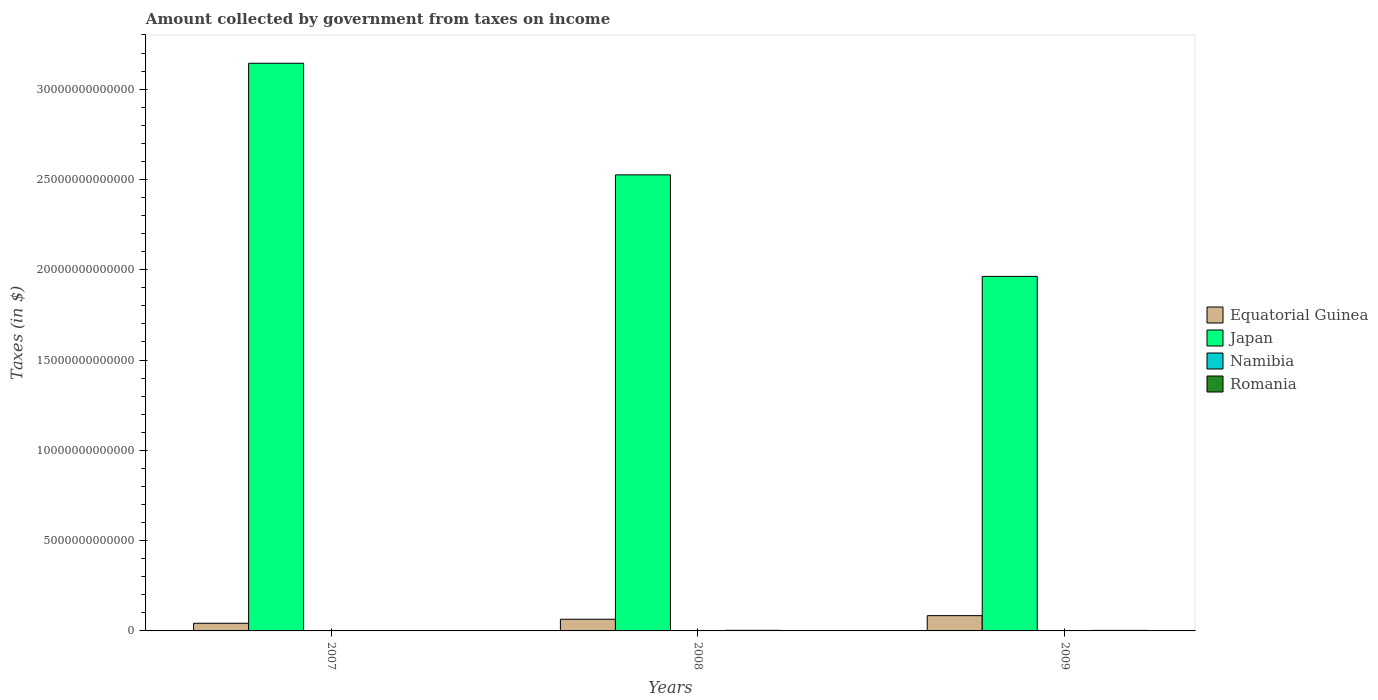How many bars are there on the 3rd tick from the right?
Offer a terse response. 4. What is the label of the 3rd group of bars from the left?
Ensure brevity in your answer.  2009. What is the amount collected by government from taxes on income in Romania in 2007?
Make the answer very short. 1.50e+1. Across all years, what is the maximum amount collected by government from taxes on income in Namibia?
Your response must be concise. 8.14e+09. Across all years, what is the minimum amount collected by government from taxes on income in Equatorial Guinea?
Offer a terse response. 4.24e+11. In which year was the amount collected by government from taxes on income in Japan maximum?
Ensure brevity in your answer.  2007. What is the total amount collected by government from taxes on income in Equatorial Guinea in the graph?
Offer a very short reply. 1.92e+12. What is the difference between the amount collected by government from taxes on income in Romania in 2008 and that in 2009?
Provide a short and direct response. 3.39e+09. What is the difference between the amount collected by government from taxes on income in Equatorial Guinea in 2007 and the amount collected by government from taxes on income in Namibia in 2009?
Your answer should be very brief. 4.16e+11. What is the average amount collected by government from taxes on income in Romania per year?
Offer a very short reply. 2.65e+1. In the year 2008, what is the difference between the amount collected by government from taxes on income in Namibia and amount collected by government from taxes on income in Equatorial Guinea?
Keep it short and to the point. -6.39e+11. In how many years, is the amount collected by government from taxes on income in Namibia greater than 23000000000000 $?
Offer a very short reply. 0. What is the ratio of the amount collected by government from taxes on income in Japan in 2007 to that in 2009?
Your answer should be very brief. 1.6. Is the amount collected by government from taxes on income in Romania in 2007 less than that in 2009?
Provide a short and direct response. Yes. Is the difference between the amount collected by government from taxes on income in Namibia in 2007 and 2008 greater than the difference between the amount collected by government from taxes on income in Equatorial Guinea in 2007 and 2008?
Make the answer very short. Yes. What is the difference between the highest and the second highest amount collected by government from taxes on income in Namibia?
Make the answer very short. 6.70e+07. What is the difference between the highest and the lowest amount collected by government from taxes on income in Japan?
Provide a succinct answer. 1.18e+13. In how many years, is the amount collected by government from taxes on income in Equatorial Guinea greater than the average amount collected by government from taxes on income in Equatorial Guinea taken over all years?
Keep it short and to the point. 2. Is it the case that in every year, the sum of the amount collected by government from taxes on income in Equatorial Guinea and amount collected by government from taxes on income in Japan is greater than the sum of amount collected by government from taxes on income in Namibia and amount collected by government from taxes on income in Romania?
Your response must be concise. Yes. What does the 1st bar from the left in 2009 represents?
Make the answer very short. Equatorial Guinea. What does the 2nd bar from the right in 2007 represents?
Offer a very short reply. Namibia. Is it the case that in every year, the sum of the amount collected by government from taxes on income in Equatorial Guinea and amount collected by government from taxes on income in Romania is greater than the amount collected by government from taxes on income in Namibia?
Your answer should be compact. Yes. Are all the bars in the graph horizontal?
Offer a very short reply. No. What is the difference between two consecutive major ticks on the Y-axis?
Ensure brevity in your answer.  5.00e+12. Does the graph contain any zero values?
Make the answer very short. No. Where does the legend appear in the graph?
Your response must be concise. Center right. What is the title of the graph?
Keep it short and to the point. Amount collected by government from taxes on income. What is the label or title of the Y-axis?
Keep it short and to the point. Taxes (in $). What is the Taxes (in $) of Equatorial Guinea in 2007?
Provide a short and direct response. 4.24e+11. What is the Taxes (in $) in Japan in 2007?
Your answer should be compact. 3.14e+13. What is the Taxes (in $) in Namibia in 2007?
Keep it short and to the point. 5.20e+09. What is the Taxes (in $) of Romania in 2007?
Provide a succinct answer. 1.50e+1. What is the Taxes (in $) in Equatorial Guinea in 2008?
Your response must be concise. 6.47e+11. What is the Taxes (in $) in Japan in 2008?
Offer a terse response. 2.53e+13. What is the Taxes (in $) of Namibia in 2008?
Your response must be concise. 8.07e+09. What is the Taxes (in $) of Romania in 2008?
Provide a short and direct response. 3.40e+1. What is the Taxes (in $) in Equatorial Guinea in 2009?
Give a very brief answer. 8.46e+11. What is the Taxes (in $) in Japan in 2009?
Provide a succinct answer. 1.96e+13. What is the Taxes (in $) in Namibia in 2009?
Your answer should be very brief. 8.14e+09. What is the Taxes (in $) in Romania in 2009?
Provide a short and direct response. 3.06e+1. Across all years, what is the maximum Taxes (in $) of Equatorial Guinea?
Your response must be concise. 8.46e+11. Across all years, what is the maximum Taxes (in $) in Japan?
Provide a succinct answer. 3.14e+13. Across all years, what is the maximum Taxes (in $) in Namibia?
Offer a very short reply. 8.14e+09. Across all years, what is the maximum Taxes (in $) in Romania?
Provide a short and direct response. 3.40e+1. Across all years, what is the minimum Taxes (in $) in Equatorial Guinea?
Make the answer very short. 4.24e+11. Across all years, what is the minimum Taxes (in $) in Japan?
Give a very brief answer. 1.96e+13. Across all years, what is the minimum Taxes (in $) of Namibia?
Offer a very short reply. 5.20e+09. Across all years, what is the minimum Taxes (in $) of Romania?
Ensure brevity in your answer.  1.50e+1. What is the total Taxes (in $) of Equatorial Guinea in the graph?
Your answer should be very brief. 1.92e+12. What is the total Taxes (in $) of Japan in the graph?
Provide a succinct answer. 7.63e+13. What is the total Taxes (in $) in Namibia in the graph?
Offer a terse response. 2.14e+1. What is the total Taxes (in $) in Romania in the graph?
Make the answer very short. 7.96e+1. What is the difference between the Taxes (in $) in Equatorial Guinea in 2007 and that in 2008?
Provide a short and direct response. -2.23e+11. What is the difference between the Taxes (in $) of Japan in 2007 and that in 2008?
Keep it short and to the point. 6.18e+12. What is the difference between the Taxes (in $) of Namibia in 2007 and that in 2008?
Ensure brevity in your answer.  -2.87e+09. What is the difference between the Taxes (in $) of Romania in 2007 and that in 2008?
Ensure brevity in your answer.  -1.90e+1. What is the difference between the Taxes (in $) of Equatorial Guinea in 2007 and that in 2009?
Make the answer very short. -4.22e+11. What is the difference between the Taxes (in $) in Japan in 2007 and that in 2009?
Provide a short and direct response. 1.18e+13. What is the difference between the Taxes (in $) in Namibia in 2007 and that in 2009?
Offer a terse response. -2.94e+09. What is the difference between the Taxes (in $) of Romania in 2007 and that in 2009?
Keep it short and to the point. -1.56e+1. What is the difference between the Taxes (in $) in Equatorial Guinea in 2008 and that in 2009?
Provide a short and direct response. -1.99e+11. What is the difference between the Taxes (in $) in Japan in 2008 and that in 2009?
Offer a terse response. 5.62e+12. What is the difference between the Taxes (in $) in Namibia in 2008 and that in 2009?
Your answer should be very brief. -6.70e+07. What is the difference between the Taxes (in $) of Romania in 2008 and that in 2009?
Make the answer very short. 3.39e+09. What is the difference between the Taxes (in $) in Equatorial Guinea in 2007 and the Taxes (in $) in Japan in 2008?
Keep it short and to the point. -2.48e+13. What is the difference between the Taxes (in $) of Equatorial Guinea in 2007 and the Taxes (in $) of Namibia in 2008?
Keep it short and to the point. 4.16e+11. What is the difference between the Taxes (in $) of Equatorial Guinea in 2007 and the Taxes (in $) of Romania in 2008?
Your response must be concise. 3.90e+11. What is the difference between the Taxes (in $) of Japan in 2007 and the Taxes (in $) of Namibia in 2008?
Provide a succinct answer. 3.14e+13. What is the difference between the Taxes (in $) in Japan in 2007 and the Taxes (in $) in Romania in 2008?
Offer a very short reply. 3.14e+13. What is the difference between the Taxes (in $) of Namibia in 2007 and the Taxes (in $) of Romania in 2008?
Offer a very short reply. -2.88e+1. What is the difference between the Taxes (in $) of Equatorial Guinea in 2007 and the Taxes (in $) of Japan in 2009?
Keep it short and to the point. -1.92e+13. What is the difference between the Taxes (in $) in Equatorial Guinea in 2007 and the Taxes (in $) in Namibia in 2009?
Ensure brevity in your answer.  4.16e+11. What is the difference between the Taxes (in $) in Equatorial Guinea in 2007 and the Taxes (in $) in Romania in 2009?
Make the answer very short. 3.93e+11. What is the difference between the Taxes (in $) of Japan in 2007 and the Taxes (in $) of Namibia in 2009?
Ensure brevity in your answer.  3.14e+13. What is the difference between the Taxes (in $) of Japan in 2007 and the Taxes (in $) of Romania in 2009?
Offer a very short reply. 3.14e+13. What is the difference between the Taxes (in $) of Namibia in 2007 and the Taxes (in $) of Romania in 2009?
Ensure brevity in your answer.  -2.54e+1. What is the difference between the Taxes (in $) in Equatorial Guinea in 2008 and the Taxes (in $) in Japan in 2009?
Ensure brevity in your answer.  -1.90e+13. What is the difference between the Taxes (in $) of Equatorial Guinea in 2008 and the Taxes (in $) of Namibia in 2009?
Offer a very short reply. 6.39e+11. What is the difference between the Taxes (in $) in Equatorial Guinea in 2008 and the Taxes (in $) in Romania in 2009?
Keep it short and to the point. 6.16e+11. What is the difference between the Taxes (in $) of Japan in 2008 and the Taxes (in $) of Namibia in 2009?
Ensure brevity in your answer.  2.52e+13. What is the difference between the Taxes (in $) in Japan in 2008 and the Taxes (in $) in Romania in 2009?
Your answer should be very brief. 2.52e+13. What is the difference between the Taxes (in $) in Namibia in 2008 and the Taxes (in $) in Romania in 2009?
Your response must be concise. -2.25e+1. What is the average Taxes (in $) in Equatorial Guinea per year?
Provide a short and direct response. 6.39e+11. What is the average Taxes (in $) in Japan per year?
Your answer should be very brief. 2.54e+13. What is the average Taxes (in $) of Namibia per year?
Offer a very short reply. 7.14e+09. What is the average Taxes (in $) in Romania per year?
Your response must be concise. 2.65e+1. In the year 2007, what is the difference between the Taxes (in $) of Equatorial Guinea and Taxes (in $) of Japan?
Your answer should be compact. -3.10e+13. In the year 2007, what is the difference between the Taxes (in $) of Equatorial Guinea and Taxes (in $) of Namibia?
Offer a very short reply. 4.19e+11. In the year 2007, what is the difference between the Taxes (in $) of Equatorial Guinea and Taxes (in $) of Romania?
Make the answer very short. 4.09e+11. In the year 2007, what is the difference between the Taxes (in $) in Japan and Taxes (in $) in Namibia?
Give a very brief answer. 3.14e+13. In the year 2007, what is the difference between the Taxes (in $) of Japan and Taxes (in $) of Romania?
Offer a very short reply. 3.14e+13. In the year 2007, what is the difference between the Taxes (in $) in Namibia and Taxes (in $) in Romania?
Your response must be concise. -9.82e+09. In the year 2008, what is the difference between the Taxes (in $) in Equatorial Guinea and Taxes (in $) in Japan?
Provide a succinct answer. -2.46e+13. In the year 2008, what is the difference between the Taxes (in $) of Equatorial Guinea and Taxes (in $) of Namibia?
Give a very brief answer. 6.39e+11. In the year 2008, what is the difference between the Taxes (in $) in Equatorial Guinea and Taxes (in $) in Romania?
Your response must be concise. 6.13e+11. In the year 2008, what is the difference between the Taxes (in $) of Japan and Taxes (in $) of Namibia?
Keep it short and to the point. 2.52e+13. In the year 2008, what is the difference between the Taxes (in $) of Japan and Taxes (in $) of Romania?
Give a very brief answer. 2.52e+13. In the year 2008, what is the difference between the Taxes (in $) of Namibia and Taxes (in $) of Romania?
Offer a very short reply. -2.59e+1. In the year 2009, what is the difference between the Taxes (in $) in Equatorial Guinea and Taxes (in $) in Japan?
Offer a terse response. -1.88e+13. In the year 2009, what is the difference between the Taxes (in $) of Equatorial Guinea and Taxes (in $) of Namibia?
Your answer should be very brief. 8.38e+11. In the year 2009, what is the difference between the Taxes (in $) of Equatorial Guinea and Taxes (in $) of Romania?
Provide a succinct answer. 8.16e+11. In the year 2009, what is the difference between the Taxes (in $) in Japan and Taxes (in $) in Namibia?
Provide a short and direct response. 1.96e+13. In the year 2009, what is the difference between the Taxes (in $) of Japan and Taxes (in $) of Romania?
Give a very brief answer. 1.96e+13. In the year 2009, what is the difference between the Taxes (in $) in Namibia and Taxes (in $) in Romania?
Ensure brevity in your answer.  -2.25e+1. What is the ratio of the Taxes (in $) of Equatorial Guinea in 2007 to that in 2008?
Ensure brevity in your answer.  0.66. What is the ratio of the Taxes (in $) in Japan in 2007 to that in 2008?
Give a very brief answer. 1.24. What is the ratio of the Taxes (in $) in Namibia in 2007 to that in 2008?
Offer a very short reply. 0.64. What is the ratio of the Taxes (in $) of Romania in 2007 to that in 2008?
Your answer should be very brief. 0.44. What is the ratio of the Taxes (in $) of Equatorial Guinea in 2007 to that in 2009?
Make the answer very short. 0.5. What is the ratio of the Taxes (in $) in Japan in 2007 to that in 2009?
Offer a terse response. 1.6. What is the ratio of the Taxes (in $) in Namibia in 2007 to that in 2009?
Provide a short and direct response. 0.64. What is the ratio of the Taxes (in $) in Romania in 2007 to that in 2009?
Offer a terse response. 0.49. What is the ratio of the Taxes (in $) in Equatorial Guinea in 2008 to that in 2009?
Your answer should be compact. 0.76. What is the ratio of the Taxes (in $) of Japan in 2008 to that in 2009?
Keep it short and to the point. 1.29. What is the ratio of the Taxes (in $) in Romania in 2008 to that in 2009?
Provide a short and direct response. 1.11. What is the difference between the highest and the second highest Taxes (in $) of Equatorial Guinea?
Offer a very short reply. 1.99e+11. What is the difference between the highest and the second highest Taxes (in $) in Japan?
Ensure brevity in your answer.  6.18e+12. What is the difference between the highest and the second highest Taxes (in $) in Namibia?
Make the answer very short. 6.70e+07. What is the difference between the highest and the second highest Taxes (in $) in Romania?
Your answer should be very brief. 3.39e+09. What is the difference between the highest and the lowest Taxes (in $) in Equatorial Guinea?
Give a very brief answer. 4.22e+11. What is the difference between the highest and the lowest Taxes (in $) of Japan?
Ensure brevity in your answer.  1.18e+13. What is the difference between the highest and the lowest Taxes (in $) in Namibia?
Your answer should be compact. 2.94e+09. What is the difference between the highest and the lowest Taxes (in $) of Romania?
Provide a succinct answer. 1.90e+1. 